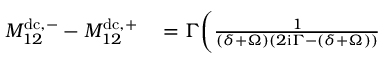Convert formula to latex. <formula><loc_0><loc_0><loc_500><loc_500>\begin{array} { r l } { M _ { 1 2 } ^ { d c , - } - M _ { 1 2 } ^ { d c , + } } & = \Gamma \Big ( \frac { 1 } { ( \delta + \Omega ) ( 2 i \Gamma - ( \delta + \Omega ) ) } } \end{array}</formula> 